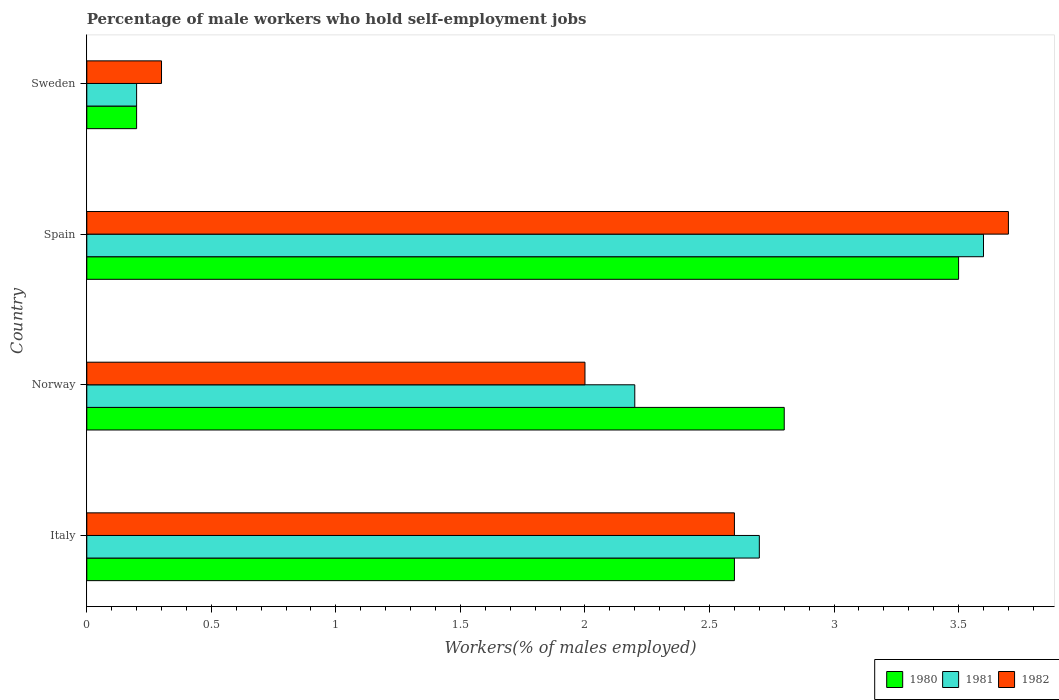How many groups of bars are there?
Your response must be concise. 4. Are the number of bars per tick equal to the number of legend labels?
Offer a very short reply. Yes. What is the label of the 3rd group of bars from the top?
Ensure brevity in your answer.  Norway. What is the percentage of self-employed male workers in 1982 in Spain?
Your answer should be compact. 3.7. Across all countries, what is the maximum percentage of self-employed male workers in 1982?
Provide a short and direct response. 3.7. Across all countries, what is the minimum percentage of self-employed male workers in 1982?
Your response must be concise. 0.3. What is the total percentage of self-employed male workers in 1982 in the graph?
Provide a short and direct response. 8.6. What is the difference between the percentage of self-employed male workers in 1982 in Italy and that in Spain?
Give a very brief answer. -1.1. What is the difference between the percentage of self-employed male workers in 1982 in Spain and the percentage of self-employed male workers in 1980 in Sweden?
Ensure brevity in your answer.  3.5. What is the average percentage of self-employed male workers in 1982 per country?
Keep it short and to the point. 2.15. What is the difference between the percentage of self-employed male workers in 1981 and percentage of self-employed male workers in 1980 in Spain?
Ensure brevity in your answer.  0.1. What is the ratio of the percentage of self-employed male workers in 1982 in Norway to that in Sweden?
Give a very brief answer. 6.67. Is the percentage of self-employed male workers in 1981 in Spain less than that in Sweden?
Offer a very short reply. No. Is the difference between the percentage of self-employed male workers in 1981 in Norway and Sweden greater than the difference between the percentage of self-employed male workers in 1980 in Norway and Sweden?
Your answer should be compact. No. What is the difference between the highest and the second highest percentage of self-employed male workers in 1980?
Offer a very short reply. 0.7. What is the difference between the highest and the lowest percentage of self-employed male workers in 1982?
Offer a very short reply. 3.4. In how many countries, is the percentage of self-employed male workers in 1982 greater than the average percentage of self-employed male workers in 1982 taken over all countries?
Offer a terse response. 2. Is the sum of the percentage of self-employed male workers in 1980 in Norway and Sweden greater than the maximum percentage of self-employed male workers in 1981 across all countries?
Provide a short and direct response. No. What does the 2nd bar from the top in Sweden represents?
Provide a succinct answer. 1981. Is it the case that in every country, the sum of the percentage of self-employed male workers in 1981 and percentage of self-employed male workers in 1980 is greater than the percentage of self-employed male workers in 1982?
Ensure brevity in your answer.  Yes. How many countries are there in the graph?
Make the answer very short. 4. Where does the legend appear in the graph?
Make the answer very short. Bottom right. How are the legend labels stacked?
Give a very brief answer. Horizontal. What is the title of the graph?
Ensure brevity in your answer.  Percentage of male workers who hold self-employment jobs. What is the label or title of the X-axis?
Offer a very short reply. Workers(% of males employed). What is the label or title of the Y-axis?
Your answer should be very brief. Country. What is the Workers(% of males employed) in 1980 in Italy?
Offer a very short reply. 2.6. What is the Workers(% of males employed) of 1981 in Italy?
Your answer should be very brief. 2.7. What is the Workers(% of males employed) in 1982 in Italy?
Ensure brevity in your answer.  2.6. What is the Workers(% of males employed) in 1980 in Norway?
Your response must be concise. 2.8. What is the Workers(% of males employed) in 1981 in Norway?
Provide a short and direct response. 2.2. What is the Workers(% of males employed) in 1982 in Norway?
Provide a short and direct response. 2. What is the Workers(% of males employed) of 1980 in Spain?
Give a very brief answer. 3.5. What is the Workers(% of males employed) of 1981 in Spain?
Make the answer very short. 3.6. What is the Workers(% of males employed) in 1982 in Spain?
Offer a very short reply. 3.7. What is the Workers(% of males employed) of 1980 in Sweden?
Your response must be concise. 0.2. What is the Workers(% of males employed) in 1981 in Sweden?
Make the answer very short. 0.2. What is the Workers(% of males employed) in 1982 in Sweden?
Offer a terse response. 0.3. Across all countries, what is the maximum Workers(% of males employed) of 1980?
Ensure brevity in your answer.  3.5. Across all countries, what is the maximum Workers(% of males employed) in 1981?
Your answer should be very brief. 3.6. Across all countries, what is the maximum Workers(% of males employed) in 1982?
Give a very brief answer. 3.7. Across all countries, what is the minimum Workers(% of males employed) in 1980?
Provide a succinct answer. 0.2. Across all countries, what is the minimum Workers(% of males employed) in 1981?
Provide a short and direct response. 0.2. Across all countries, what is the minimum Workers(% of males employed) in 1982?
Your answer should be very brief. 0.3. What is the difference between the Workers(% of males employed) in 1980 in Italy and that in Norway?
Keep it short and to the point. -0.2. What is the difference between the Workers(% of males employed) of 1981 in Italy and that in Norway?
Your response must be concise. 0.5. What is the difference between the Workers(% of males employed) in 1982 in Italy and that in Norway?
Make the answer very short. 0.6. What is the difference between the Workers(% of males employed) in 1982 in Italy and that in Spain?
Your answer should be very brief. -1.1. What is the difference between the Workers(% of males employed) in 1980 in Italy and that in Sweden?
Offer a terse response. 2.4. What is the difference between the Workers(% of males employed) of 1981 in Italy and that in Sweden?
Offer a very short reply. 2.5. What is the difference between the Workers(% of males employed) of 1980 in Norway and that in Sweden?
Your answer should be compact. 2.6. What is the difference between the Workers(% of males employed) of 1981 in Norway and that in Sweden?
Give a very brief answer. 2. What is the difference between the Workers(% of males employed) in 1980 in Spain and that in Sweden?
Give a very brief answer. 3.3. What is the difference between the Workers(% of males employed) of 1982 in Spain and that in Sweden?
Ensure brevity in your answer.  3.4. What is the difference between the Workers(% of males employed) of 1981 in Italy and the Workers(% of males employed) of 1982 in Norway?
Your response must be concise. 0.7. What is the difference between the Workers(% of males employed) of 1981 in Italy and the Workers(% of males employed) of 1982 in Spain?
Your answer should be compact. -1. What is the difference between the Workers(% of males employed) in 1980 in Italy and the Workers(% of males employed) in 1981 in Sweden?
Your answer should be very brief. 2.4. What is the difference between the Workers(% of males employed) of 1980 in Italy and the Workers(% of males employed) of 1982 in Sweden?
Ensure brevity in your answer.  2.3. What is the difference between the Workers(% of males employed) in 1980 in Norway and the Workers(% of males employed) in 1982 in Sweden?
Your answer should be compact. 2.5. What is the difference between the Workers(% of males employed) of 1980 in Spain and the Workers(% of males employed) of 1981 in Sweden?
Make the answer very short. 3.3. What is the average Workers(% of males employed) in 1980 per country?
Your answer should be compact. 2.27. What is the average Workers(% of males employed) in 1981 per country?
Your answer should be very brief. 2.17. What is the average Workers(% of males employed) in 1982 per country?
Your answer should be very brief. 2.15. What is the difference between the Workers(% of males employed) in 1981 and Workers(% of males employed) in 1982 in Italy?
Your response must be concise. 0.1. What is the difference between the Workers(% of males employed) in 1980 and Workers(% of males employed) in 1982 in Norway?
Keep it short and to the point. 0.8. What is the difference between the Workers(% of males employed) in 1981 and Workers(% of males employed) in 1982 in Norway?
Your answer should be very brief. 0.2. What is the difference between the Workers(% of males employed) in 1981 and Workers(% of males employed) in 1982 in Spain?
Make the answer very short. -0.1. What is the difference between the Workers(% of males employed) in 1981 and Workers(% of males employed) in 1982 in Sweden?
Your answer should be compact. -0.1. What is the ratio of the Workers(% of males employed) of 1980 in Italy to that in Norway?
Your answer should be very brief. 0.93. What is the ratio of the Workers(% of males employed) in 1981 in Italy to that in Norway?
Ensure brevity in your answer.  1.23. What is the ratio of the Workers(% of males employed) in 1980 in Italy to that in Spain?
Keep it short and to the point. 0.74. What is the ratio of the Workers(% of males employed) in 1982 in Italy to that in Spain?
Your answer should be compact. 0.7. What is the ratio of the Workers(% of males employed) in 1982 in Italy to that in Sweden?
Your answer should be compact. 8.67. What is the ratio of the Workers(% of males employed) in 1980 in Norway to that in Spain?
Your answer should be compact. 0.8. What is the ratio of the Workers(% of males employed) of 1981 in Norway to that in Spain?
Provide a short and direct response. 0.61. What is the ratio of the Workers(% of males employed) in 1982 in Norway to that in Spain?
Your answer should be very brief. 0.54. What is the ratio of the Workers(% of males employed) in 1982 in Norway to that in Sweden?
Offer a very short reply. 6.67. What is the ratio of the Workers(% of males employed) of 1980 in Spain to that in Sweden?
Provide a short and direct response. 17.5. What is the ratio of the Workers(% of males employed) of 1982 in Spain to that in Sweden?
Ensure brevity in your answer.  12.33. What is the difference between the highest and the second highest Workers(% of males employed) of 1980?
Your answer should be compact. 0.7. 